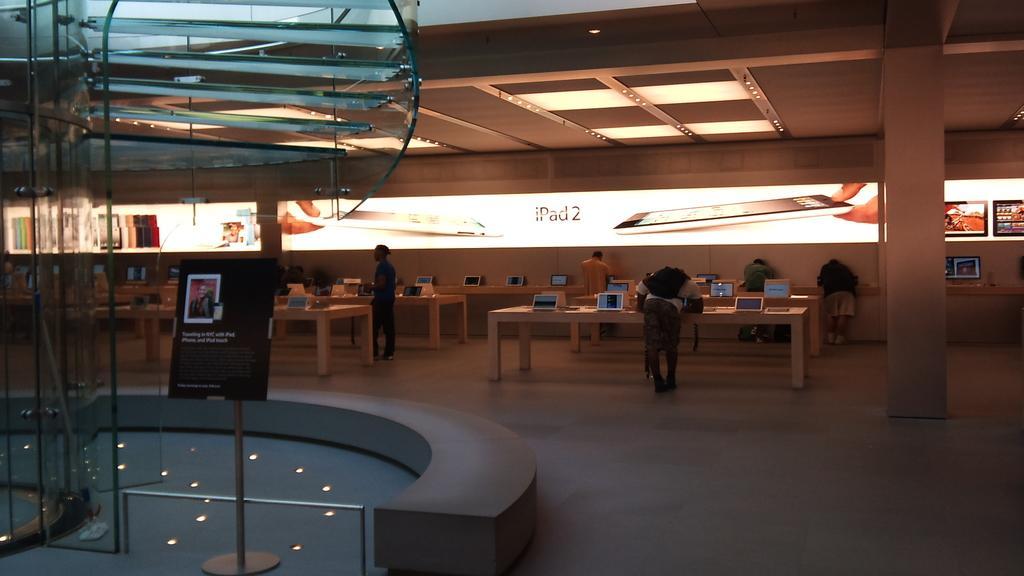Can you describe this image briefly? In this image I can see few persons some are standing and some are doing work. I can also see few ipads on the table, background I can see a glass screen. 